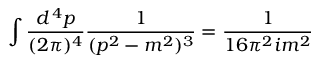<formula> <loc_0><loc_0><loc_500><loc_500>\int { \frac { d ^ { \, 4 } p } { ( 2 \pi ) ^ { 4 } } } { \frac { 1 } { ( p ^ { 2 } - m ^ { 2 } ) ^ { 3 } } } = { \frac { 1 } { 1 6 \pi ^ { 2 } i m ^ { 2 } } }</formula> 